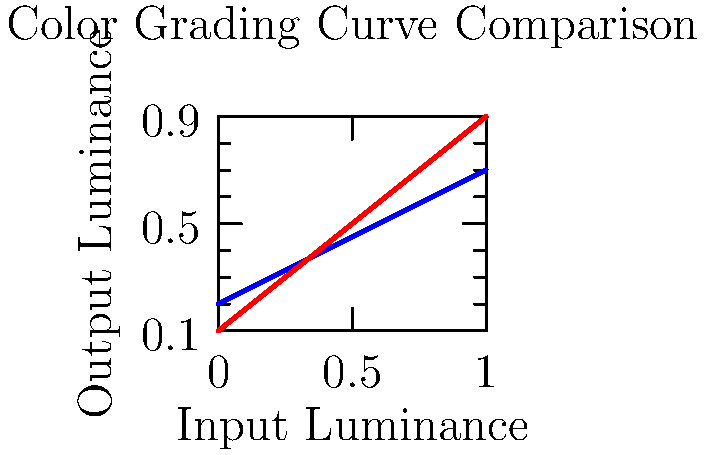In the color grading curve comparison shown above, which technique has likely been applied to achieve the "After" result, and how does it affect the overall look of the image? To determine the color grading technique applied and its effect, let's analyze the curves step-by-step:

1. Observe the "Before" curve (blue):
   - It has a moderate slope and starts slightly above the origin.
   - This represents a fairly standard, slightly lifted image.

2. Examine the "After" curve (red):
   - It has a steeper slope compared to the "Before" curve.
   - The curve starts closer to the origin.

3. Compare the two curves:
   - The "After" curve shows increased contrast across the entire tonal range.
   - Shadows are slightly darker (curve starts lower).
   - Highlights are brighter (curve ends higher).
   - Midtones have a more pronounced slope.

4. Identify the technique:
   - This change in the curve is characteristic of increasing contrast.

5. Effect on the image:
   - Darker shadows and brighter highlights create more separation between tones.
   - Midtones become more defined, enhancing image detail and perceived sharpness.
   - The overall image will appear more punchy and vibrant.

The applied technique is contrast enhancement, which gives the image more depth and visual impact by expanding the tonal range and creating more separation between dark and light areas.
Answer: Contrast enhancement, creating a more punchy and vibrant image with increased tonal separation. 